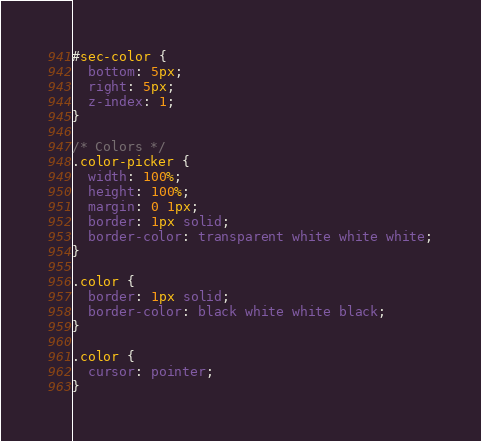<code> <loc_0><loc_0><loc_500><loc_500><_CSS_>
#sec-color {
  bottom: 5px;
  right: 5px;
  z-index: 1;
}

/* Colors */
.color-picker {
  width: 100%;
  height: 100%;
  margin: 0 1px;
  border: 1px solid;
  border-color: transparent white white white;
}

.color {
  border: 1px solid;
  border-color: black white white black;
}

.color {
  cursor: pointer;
}
</code> 